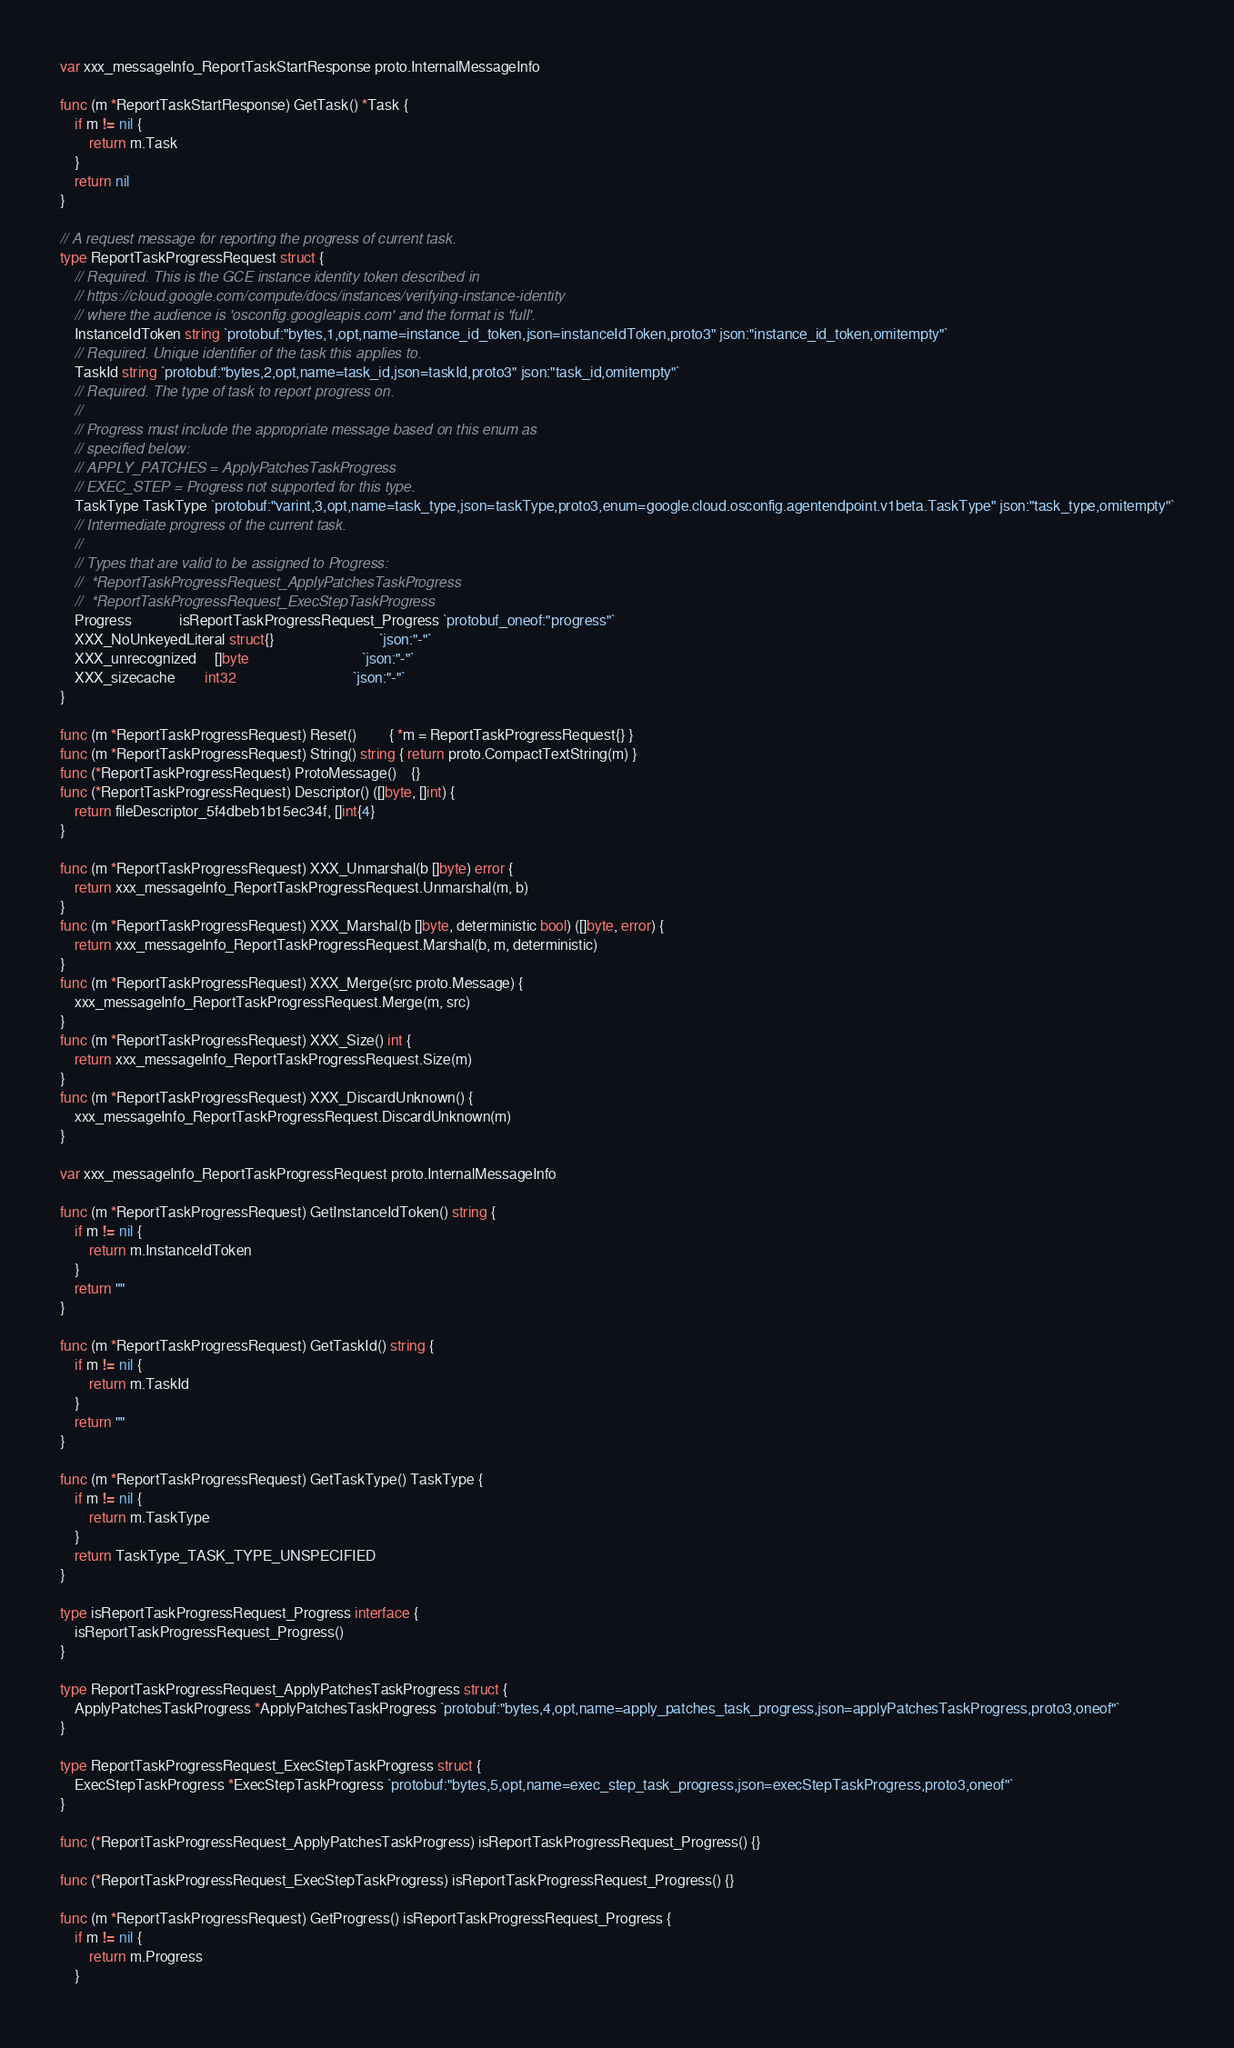<code> <loc_0><loc_0><loc_500><loc_500><_Go_>var xxx_messageInfo_ReportTaskStartResponse proto.InternalMessageInfo

func (m *ReportTaskStartResponse) GetTask() *Task {
	if m != nil {
		return m.Task
	}
	return nil
}

// A request message for reporting the progress of current task.
type ReportTaskProgressRequest struct {
	// Required. This is the GCE instance identity token described in
	// https://cloud.google.com/compute/docs/instances/verifying-instance-identity
	// where the audience is 'osconfig.googleapis.com' and the format is 'full'.
	InstanceIdToken string `protobuf:"bytes,1,opt,name=instance_id_token,json=instanceIdToken,proto3" json:"instance_id_token,omitempty"`
	// Required. Unique identifier of the task this applies to.
	TaskId string `protobuf:"bytes,2,opt,name=task_id,json=taskId,proto3" json:"task_id,omitempty"`
	// Required. The type of task to report progress on.
	//
	// Progress must include the appropriate message based on this enum as
	// specified below:
	// APPLY_PATCHES = ApplyPatchesTaskProgress
	// EXEC_STEP = Progress not supported for this type.
	TaskType TaskType `protobuf:"varint,3,opt,name=task_type,json=taskType,proto3,enum=google.cloud.osconfig.agentendpoint.v1beta.TaskType" json:"task_type,omitempty"`
	// Intermediate progress of the current task.
	//
	// Types that are valid to be assigned to Progress:
	//	*ReportTaskProgressRequest_ApplyPatchesTaskProgress
	//	*ReportTaskProgressRequest_ExecStepTaskProgress
	Progress             isReportTaskProgressRequest_Progress `protobuf_oneof:"progress"`
	XXX_NoUnkeyedLiteral struct{}                             `json:"-"`
	XXX_unrecognized     []byte                               `json:"-"`
	XXX_sizecache        int32                                `json:"-"`
}

func (m *ReportTaskProgressRequest) Reset()         { *m = ReportTaskProgressRequest{} }
func (m *ReportTaskProgressRequest) String() string { return proto.CompactTextString(m) }
func (*ReportTaskProgressRequest) ProtoMessage()    {}
func (*ReportTaskProgressRequest) Descriptor() ([]byte, []int) {
	return fileDescriptor_5f4dbeb1b15ec34f, []int{4}
}

func (m *ReportTaskProgressRequest) XXX_Unmarshal(b []byte) error {
	return xxx_messageInfo_ReportTaskProgressRequest.Unmarshal(m, b)
}
func (m *ReportTaskProgressRequest) XXX_Marshal(b []byte, deterministic bool) ([]byte, error) {
	return xxx_messageInfo_ReportTaskProgressRequest.Marshal(b, m, deterministic)
}
func (m *ReportTaskProgressRequest) XXX_Merge(src proto.Message) {
	xxx_messageInfo_ReportTaskProgressRequest.Merge(m, src)
}
func (m *ReportTaskProgressRequest) XXX_Size() int {
	return xxx_messageInfo_ReportTaskProgressRequest.Size(m)
}
func (m *ReportTaskProgressRequest) XXX_DiscardUnknown() {
	xxx_messageInfo_ReportTaskProgressRequest.DiscardUnknown(m)
}

var xxx_messageInfo_ReportTaskProgressRequest proto.InternalMessageInfo

func (m *ReportTaskProgressRequest) GetInstanceIdToken() string {
	if m != nil {
		return m.InstanceIdToken
	}
	return ""
}

func (m *ReportTaskProgressRequest) GetTaskId() string {
	if m != nil {
		return m.TaskId
	}
	return ""
}

func (m *ReportTaskProgressRequest) GetTaskType() TaskType {
	if m != nil {
		return m.TaskType
	}
	return TaskType_TASK_TYPE_UNSPECIFIED
}

type isReportTaskProgressRequest_Progress interface {
	isReportTaskProgressRequest_Progress()
}

type ReportTaskProgressRequest_ApplyPatchesTaskProgress struct {
	ApplyPatchesTaskProgress *ApplyPatchesTaskProgress `protobuf:"bytes,4,opt,name=apply_patches_task_progress,json=applyPatchesTaskProgress,proto3,oneof"`
}

type ReportTaskProgressRequest_ExecStepTaskProgress struct {
	ExecStepTaskProgress *ExecStepTaskProgress `protobuf:"bytes,5,opt,name=exec_step_task_progress,json=execStepTaskProgress,proto3,oneof"`
}

func (*ReportTaskProgressRequest_ApplyPatchesTaskProgress) isReportTaskProgressRequest_Progress() {}

func (*ReportTaskProgressRequest_ExecStepTaskProgress) isReportTaskProgressRequest_Progress() {}

func (m *ReportTaskProgressRequest) GetProgress() isReportTaskProgressRequest_Progress {
	if m != nil {
		return m.Progress
	}</code> 